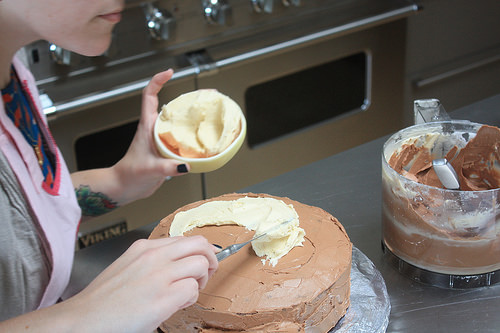<image>
Can you confirm if the frosting is on the knife? Yes. Looking at the image, I can see the frosting is positioned on top of the knife, with the knife providing support. 